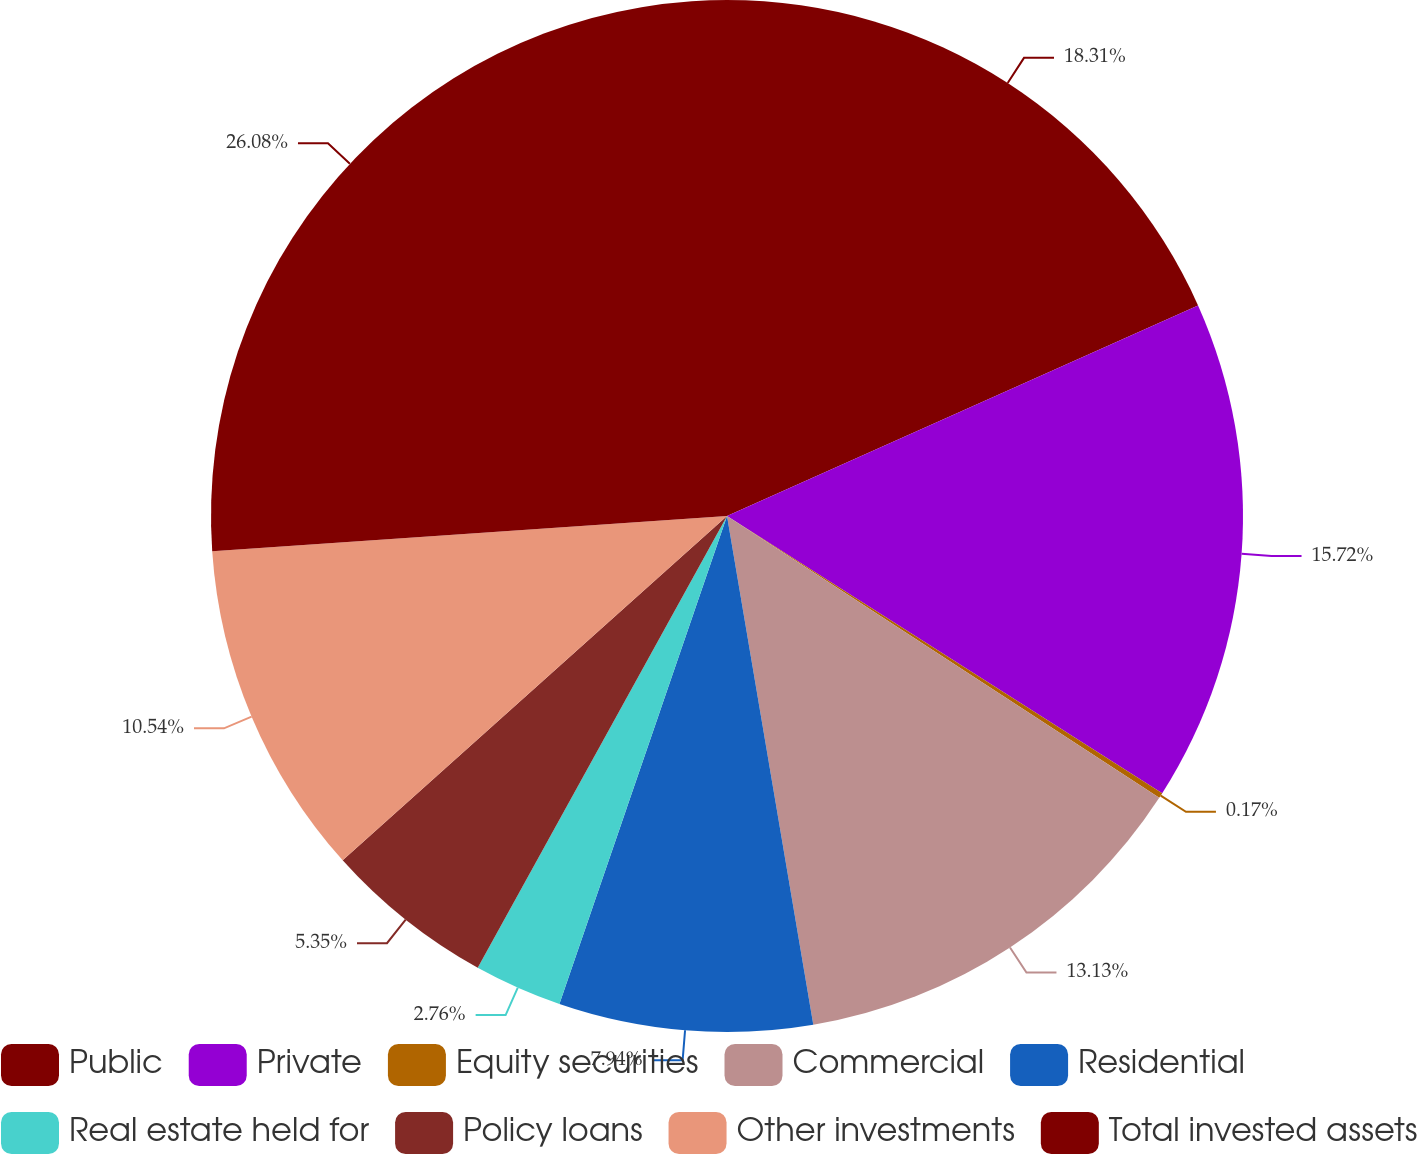<chart> <loc_0><loc_0><loc_500><loc_500><pie_chart><fcel>Public<fcel>Private<fcel>Equity securities<fcel>Commercial<fcel>Residential<fcel>Real estate held for<fcel>Policy loans<fcel>Other investments<fcel>Total invested assets<nl><fcel>18.31%<fcel>15.72%<fcel>0.17%<fcel>13.13%<fcel>7.94%<fcel>2.76%<fcel>5.35%<fcel>10.54%<fcel>26.09%<nl></chart> 